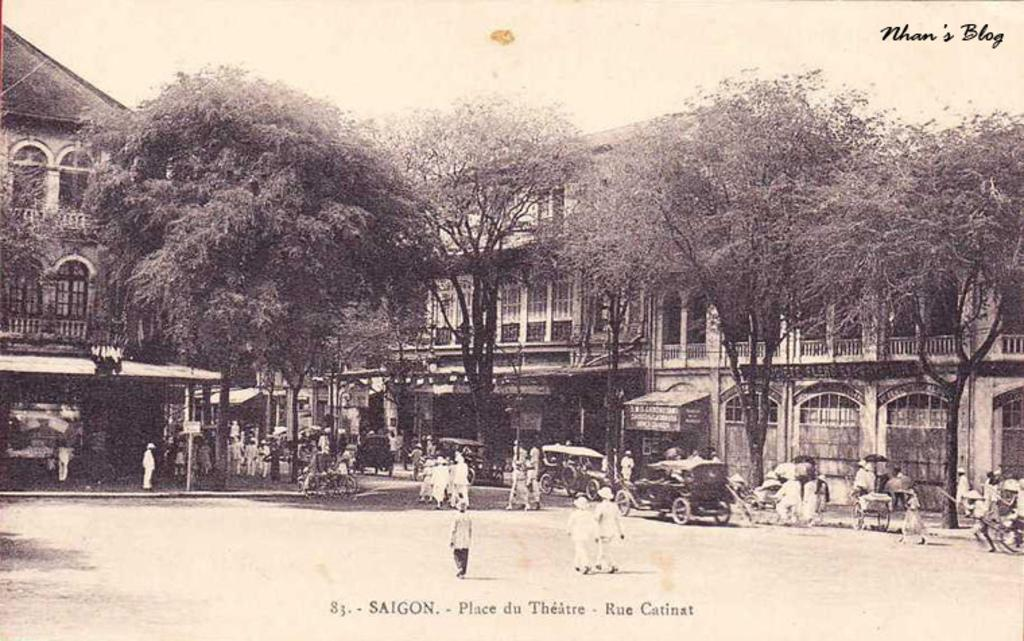What are the people in the image doing? The people in the image are walking. What else can be seen in the image besides people? There are vehicles, trees, buildings, and the sky visible in the image. Can you describe the text in the image? There is some text at the top and bottom of the image. What type of stick is being used to pay off the debt in the image? There is no mention of debt or a stick in the image. Which company is responsible for the text at the top of the image? The image does not provide information about the company associated with the text. 